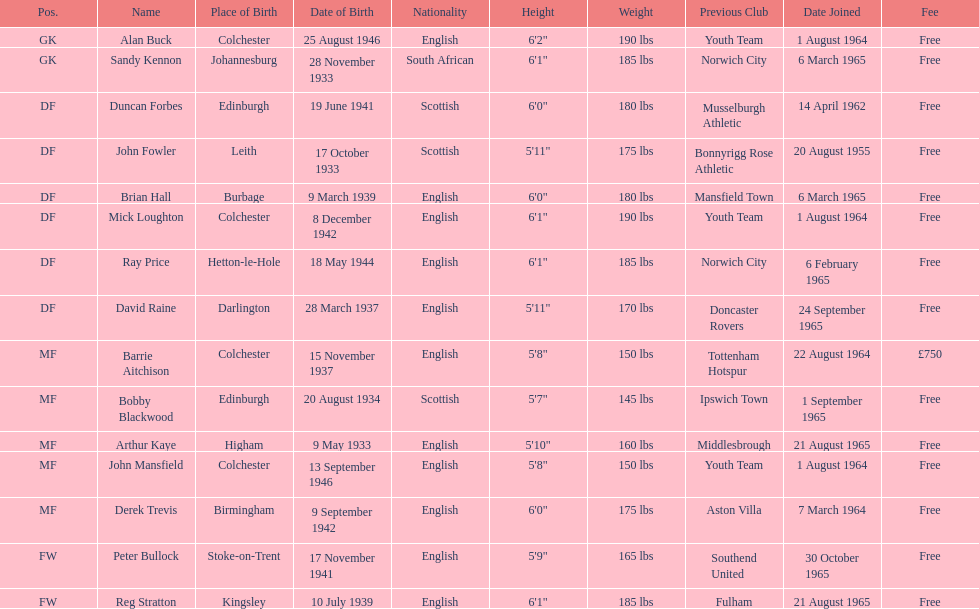Which team was ray price on before he started for this team? Norwich City. Help me parse the entirety of this table. {'header': ['Pos.', 'Name', 'Place of Birth', 'Date of Birth', 'Nationality', 'Height', 'Weight', 'Previous Club', 'Date Joined', 'Fee'], 'rows': [['GK', 'Alan Buck', 'Colchester', '25 August 1946', 'English', '6\'2"', '190 lbs', 'Youth Team', '1 August 1964', 'Free'], ['GK', 'Sandy Kennon', 'Johannesburg', '28 November 1933', 'South African', '6\'1"', '185 lbs', 'Norwich City', '6 March 1965', 'Free'], ['DF', 'Duncan Forbes', 'Edinburgh', '19 June 1941', 'Scottish', '6\'0"', '180 lbs', 'Musselburgh Athletic', '14 April 1962', 'Free'], ['DF', 'John Fowler', 'Leith', '17 October 1933', 'Scottish', '5\'11"', '175 lbs', 'Bonnyrigg Rose Athletic', '20 August 1955', 'Free'], ['DF', 'Brian Hall', 'Burbage', '9 March 1939', 'English', '6\'0"', '180 lbs', 'Mansfield Town', '6 March 1965', 'Free'], ['DF', 'Mick Loughton', 'Colchester', '8 December 1942', 'English', '6\'1"', '190 lbs', 'Youth Team', '1 August 1964', 'Free'], ['DF', 'Ray Price', 'Hetton-le-Hole', '18 May 1944', 'English', '6\'1"', '185 lbs', 'Norwich City', '6 February 1965', 'Free'], ['DF', 'David Raine', 'Darlington', '28 March 1937', 'English', '5\'11"', '170 lbs', 'Doncaster Rovers', '24 September 1965', 'Free'], ['MF', 'Barrie Aitchison', 'Colchester', '15 November 1937', 'English', '5\'8"', '150 lbs', 'Tottenham Hotspur', '22 August 1964', '£750'], ['MF', 'Bobby Blackwood', 'Edinburgh', '20 August 1934', 'Scottish', '5\'7"', '145 lbs', 'Ipswich Town', '1 September 1965', 'Free'], ['MF', 'Arthur Kaye', 'Higham', '9 May 1933', 'English', '5\'10"', '160 lbs', 'Middlesbrough', '21 August 1965', 'Free'], ['MF', 'John Mansfield', 'Colchester', '13 September 1946', 'English', '5\'8"', '150 lbs', 'Youth Team', '1 August 1964', 'Free'], ['MF', 'Derek Trevis', 'Birmingham', '9 September 1942', 'English', '6\'0"', '175 lbs', 'Aston Villa', '7 March 1964', 'Free'], ['FW', 'Peter Bullock', 'Stoke-on-Trent', '17 November 1941', 'English', '5\'9"', '165 lbs', 'Southend United', '30 October 1965', 'Free'], ['FW', 'Reg Stratton', 'Kingsley', '10 July 1939', 'English', '6\'1"', '185 lbs', 'Fulham', '21 August 1965', 'Free']]} 